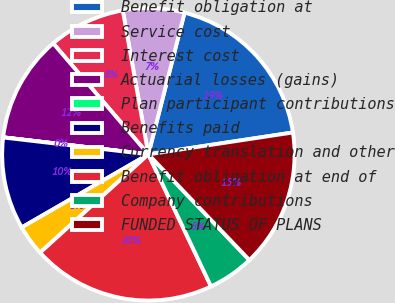Convert chart to OTSL. <chart><loc_0><loc_0><loc_500><loc_500><pie_chart><fcel>Benefit obligation at<fcel>Service cost<fcel>Interest cost<fcel>Actuarial losses (gains)<fcel>Plan participant contributions<fcel>Benefits paid<fcel>Currency translation and other<fcel>Benefit obligation at end of<fcel>Company contributions<fcel>FUNDED STATUS OF PLANS<nl><fcel>18.63%<fcel>6.78%<fcel>8.48%<fcel>11.86%<fcel>0.02%<fcel>10.17%<fcel>3.4%<fcel>20.32%<fcel>5.09%<fcel>15.25%<nl></chart> 